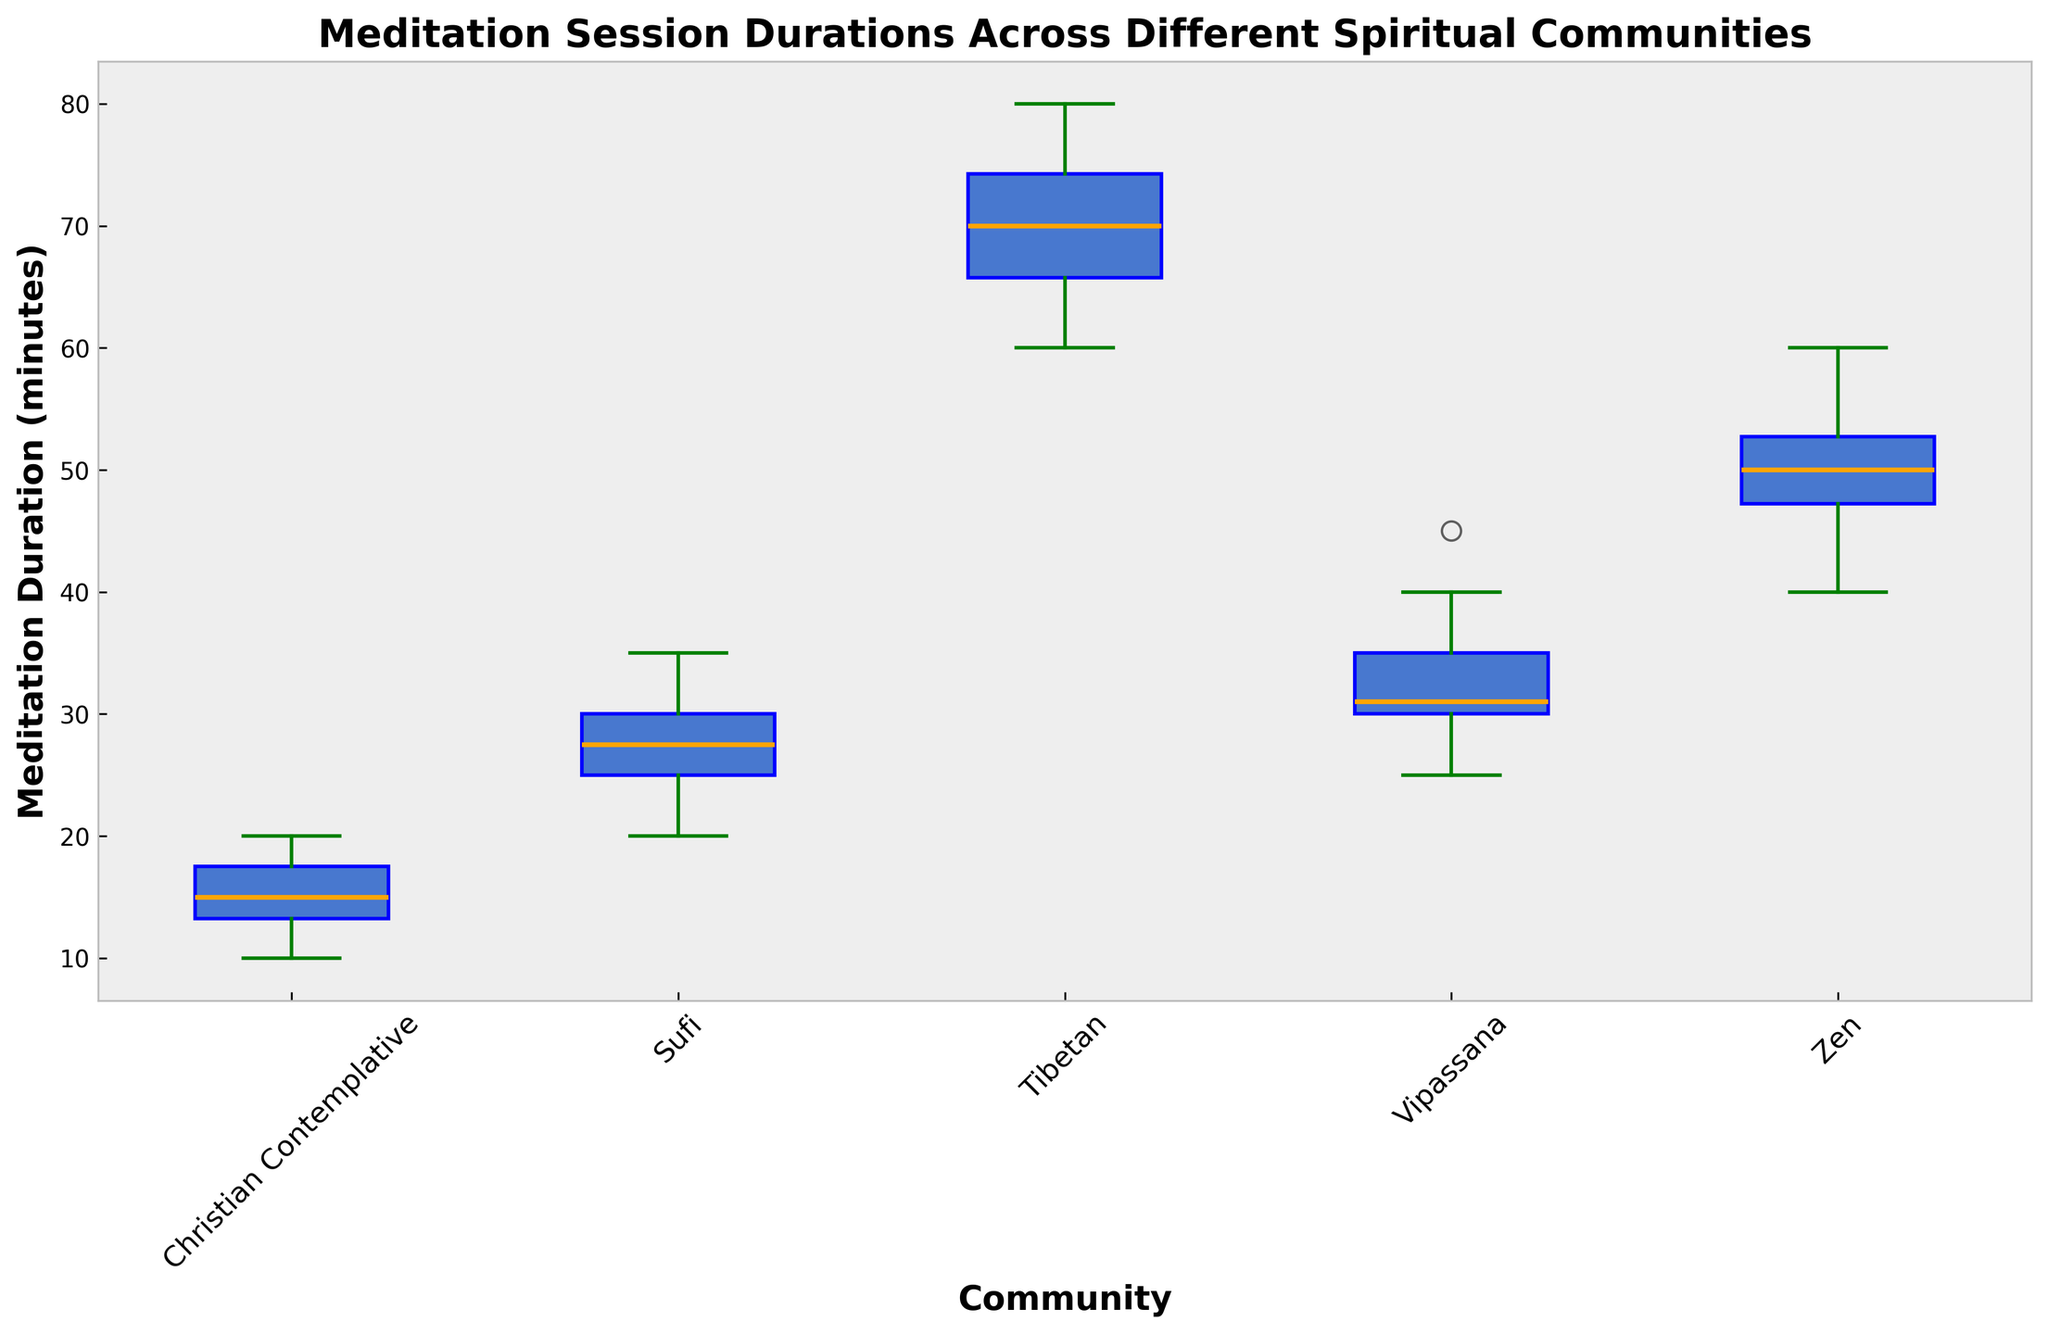what is the range of meditation durations for the Zen community? To find the range, we need to subtract the minimum value from the maximum value within the Zen community box plot. The minimum value is 40, and the maximum value is 60. Therefore, the range is 60 - 40.
Answer: 20 Which community has the longest median meditation session? The median value in each community is represented by the line inside the box. Among the different communities, the Tibetan community has the highest median value.
Answer: Tibetan How does the interquartile range (IQR) of Vipassana compare to Zen? The IQR is the difference between the 75th percentile (upper quartile) and the 25th percentile (lower quartile). From the figure, Vipassana's IQR stretches from around 30 to 40, giving an IQR of 10. Zen's IQR stretches from around 48 to 53, giving an IQR of 5. Therefore, Vipassana's IQR is larger.
Answer: Vipassana's IQR is larger Which community has the most outliers and what color represents them? Outliers are represented by the red markers outside the whiskers. The Zen and Tibetan communities each have outliers. Red markers indicate the outliers.
Answer: Zen and Tibetan; Red What is the approximate median duration compared to the mean duration of Christian Contemplative sessions? The median is indicated by the line inside the box, which is around 15 minutes. The mean can be described approximately by the center of the box, also near the middle of the lower half (around 15 minutes), suggesting the median and the mean are similar.
Answer: Approximately equal Which community's box has the longest whiskers, and what does it indicate? The Tibetan community's box has the longest whiskers, indicating that the data has a wider range and possibly more variability in meditation session durations.
Answer: Tibetan Identify the community with the shortest median meditation duration and provide the median value. The shortest median can be found for the Christian Contemplative community, indicated by the line inside the box, around 15 minutes.
Answer: Christian Contemplative; 15 What do the whiskers of the Sufi community represent, and where do they extend? The whiskers extend from the 25th percentile to the minimum value and from the 75th to the maximum value of the data points. For Sufi, the whiskers stretch from approximately 20 to 35, indicating the range of data within 1.5 times the interquartile range.
Answer: Range from 20 to 35 minutes Which community shows the least variability in meditation durations, and how can you tell? Variability is suggested by the spread of the box plot and the length of the whiskers. Zen shows the least variability as it has the narrowest box and shortest whiskers, indicating less spread in the data.
Answer: Zen 